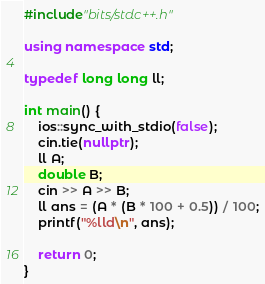<code> <loc_0><loc_0><loc_500><loc_500><_C++_>#include"bits/stdc++.h"

using namespace std;

typedef long long ll;

int main() {
	ios::sync_with_stdio(false);
	cin.tie(nullptr);
	ll A;
	double B;
	cin >> A >> B;
	ll ans = (A * (B * 100 + 0.5)) / 100;
	printf("%lld\n", ans);

	return 0;
}</code> 